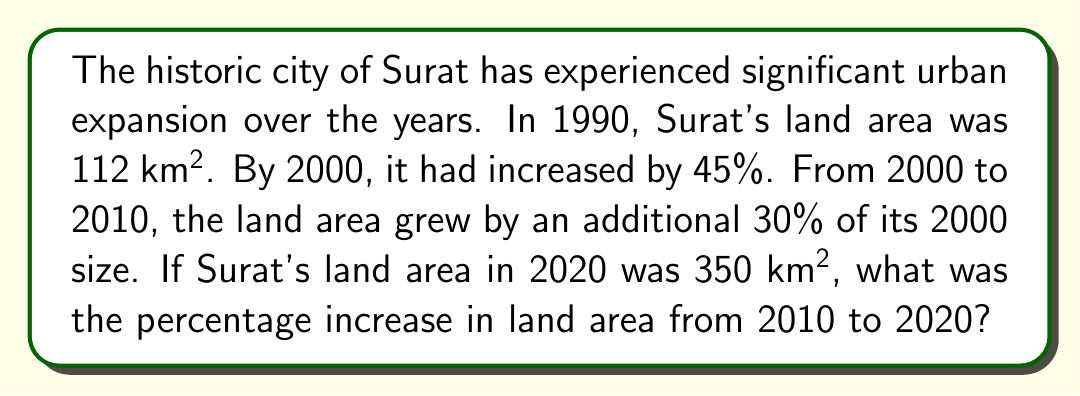Teach me how to tackle this problem. Let's approach this step-by-step:

1) First, let's calculate Surat's land area in 2000:
   $$ \text{Area}_{2000} = 112 \text{ km}^2 \times (1 + 0.45) = 162.4 \text{ km}^2 $$

2) Now, let's calculate the land area in 2010:
   $$ \text{Area}_{2010} = 162.4 \text{ km}^2 \times (1 + 0.30) = 211.12 \text{ km}^2 $$

3) We're given that the land area in 2020 was 350 km². To find the percentage increase from 2010 to 2020, we use the formula:
   $$ \text{Percentage Increase} = \frac{\text{Increase}}{\text{Original Amount}} \times 100\% $$

4) Let's calculate:
   $$ \text{Percentage Increase} = \frac{350 \text{ km}^2 - 211.12 \text{ km}^2}{211.12 \text{ km}^2} \times 100\% $$
   
   $$ = \frac{138.88 \text{ km}^2}{211.12 \text{ km}^2} \times 100\% $$
   
   $$ \approx 65.78\% $$

Therefore, the percentage increase in Surat's land area from 2010 to 2020 was approximately 65.78%.
Answer: 65.78% 